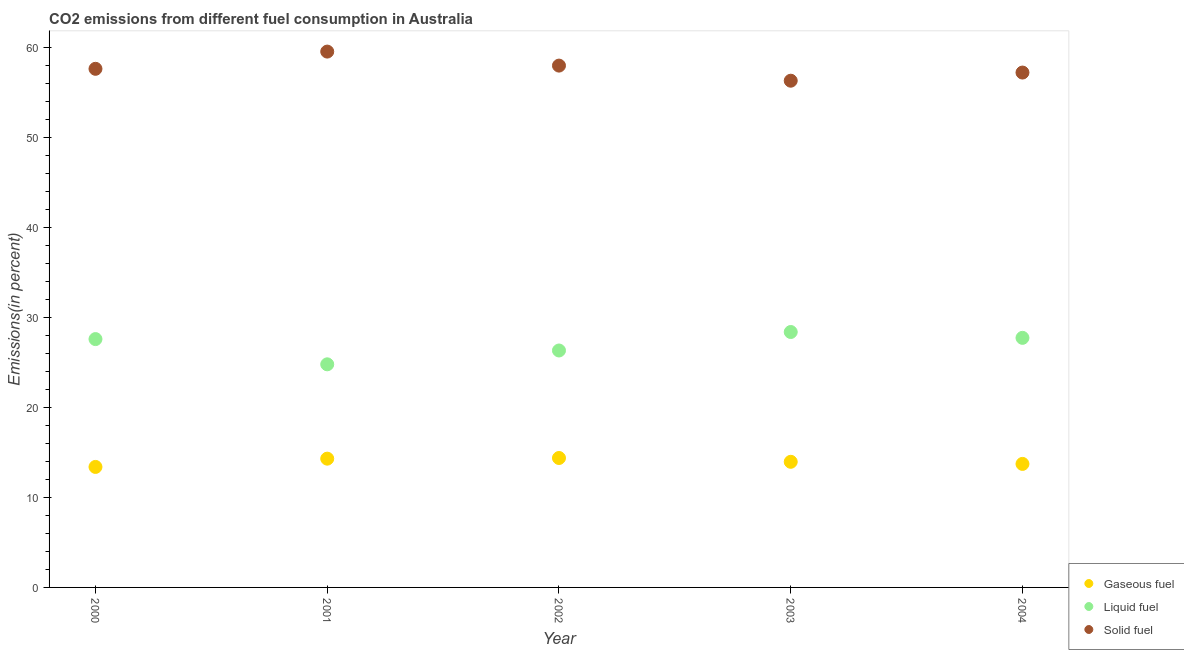How many different coloured dotlines are there?
Provide a succinct answer. 3. What is the percentage of gaseous fuel emission in 2004?
Your answer should be very brief. 13.74. Across all years, what is the maximum percentage of solid fuel emission?
Give a very brief answer. 59.58. Across all years, what is the minimum percentage of solid fuel emission?
Ensure brevity in your answer.  56.35. What is the total percentage of liquid fuel emission in the graph?
Make the answer very short. 134.93. What is the difference between the percentage of liquid fuel emission in 2000 and that in 2003?
Make the answer very short. -0.79. What is the difference between the percentage of gaseous fuel emission in 2002 and the percentage of solid fuel emission in 2004?
Provide a short and direct response. -42.86. What is the average percentage of solid fuel emission per year?
Offer a terse response. 57.78. In the year 2002, what is the difference between the percentage of solid fuel emission and percentage of gaseous fuel emission?
Provide a short and direct response. 43.63. What is the ratio of the percentage of solid fuel emission in 2000 to that in 2002?
Give a very brief answer. 0.99. Is the difference between the percentage of liquid fuel emission in 2001 and 2002 greater than the difference between the percentage of solid fuel emission in 2001 and 2002?
Keep it short and to the point. No. What is the difference between the highest and the second highest percentage of liquid fuel emission?
Offer a terse response. 0.65. What is the difference between the highest and the lowest percentage of liquid fuel emission?
Give a very brief answer. 3.59. In how many years, is the percentage of solid fuel emission greater than the average percentage of solid fuel emission taken over all years?
Provide a succinct answer. 2. How many years are there in the graph?
Your answer should be very brief. 5. What is the difference between two consecutive major ticks on the Y-axis?
Your response must be concise. 10. Does the graph contain any zero values?
Ensure brevity in your answer.  No. Where does the legend appear in the graph?
Ensure brevity in your answer.  Bottom right. How are the legend labels stacked?
Offer a terse response. Vertical. What is the title of the graph?
Offer a very short reply. CO2 emissions from different fuel consumption in Australia. What is the label or title of the Y-axis?
Provide a short and direct response. Emissions(in percent). What is the Emissions(in percent) of Gaseous fuel in 2000?
Your answer should be compact. 13.4. What is the Emissions(in percent) of Liquid fuel in 2000?
Your answer should be compact. 27.61. What is the Emissions(in percent) of Solid fuel in 2000?
Provide a short and direct response. 57.67. What is the Emissions(in percent) in Gaseous fuel in 2001?
Your answer should be very brief. 14.32. What is the Emissions(in percent) in Liquid fuel in 2001?
Offer a very short reply. 24.81. What is the Emissions(in percent) in Solid fuel in 2001?
Keep it short and to the point. 59.58. What is the Emissions(in percent) of Gaseous fuel in 2002?
Your answer should be very brief. 14.39. What is the Emissions(in percent) of Liquid fuel in 2002?
Keep it short and to the point. 26.35. What is the Emissions(in percent) in Solid fuel in 2002?
Your answer should be very brief. 58.03. What is the Emissions(in percent) in Gaseous fuel in 2003?
Keep it short and to the point. 13.97. What is the Emissions(in percent) in Liquid fuel in 2003?
Offer a very short reply. 28.4. What is the Emissions(in percent) in Solid fuel in 2003?
Your answer should be very brief. 56.35. What is the Emissions(in percent) in Gaseous fuel in 2004?
Offer a very short reply. 13.74. What is the Emissions(in percent) in Liquid fuel in 2004?
Your response must be concise. 27.75. What is the Emissions(in percent) in Solid fuel in 2004?
Provide a short and direct response. 57.25. Across all years, what is the maximum Emissions(in percent) in Gaseous fuel?
Keep it short and to the point. 14.39. Across all years, what is the maximum Emissions(in percent) in Liquid fuel?
Provide a short and direct response. 28.4. Across all years, what is the maximum Emissions(in percent) of Solid fuel?
Provide a succinct answer. 59.58. Across all years, what is the minimum Emissions(in percent) in Gaseous fuel?
Offer a terse response. 13.4. Across all years, what is the minimum Emissions(in percent) in Liquid fuel?
Offer a terse response. 24.81. Across all years, what is the minimum Emissions(in percent) of Solid fuel?
Offer a terse response. 56.35. What is the total Emissions(in percent) in Gaseous fuel in the graph?
Your answer should be compact. 69.81. What is the total Emissions(in percent) of Liquid fuel in the graph?
Give a very brief answer. 134.93. What is the total Emissions(in percent) of Solid fuel in the graph?
Ensure brevity in your answer.  288.88. What is the difference between the Emissions(in percent) of Gaseous fuel in 2000 and that in 2001?
Your response must be concise. -0.92. What is the difference between the Emissions(in percent) of Liquid fuel in 2000 and that in 2001?
Ensure brevity in your answer.  2.81. What is the difference between the Emissions(in percent) of Solid fuel in 2000 and that in 2001?
Provide a succinct answer. -1.92. What is the difference between the Emissions(in percent) in Gaseous fuel in 2000 and that in 2002?
Offer a terse response. -0.99. What is the difference between the Emissions(in percent) in Liquid fuel in 2000 and that in 2002?
Provide a succinct answer. 1.27. What is the difference between the Emissions(in percent) in Solid fuel in 2000 and that in 2002?
Give a very brief answer. -0.36. What is the difference between the Emissions(in percent) of Gaseous fuel in 2000 and that in 2003?
Give a very brief answer. -0.57. What is the difference between the Emissions(in percent) of Liquid fuel in 2000 and that in 2003?
Make the answer very short. -0.79. What is the difference between the Emissions(in percent) in Solid fuel in 2000 and that in 2003?
Make the answer very short. 1.32. What is the difference between the Emissions(in percent) of Gaseous fuel in 2000 and that in 2004?
Give a very brief answer. -0.34. What is the difference between the Emissions(in percent) in Liquid fuel in 2000 and that in 2004?
Ensure brevity in your answer.  -0.14. What is the difference between the Emissions(in percent) in Solid fuel in 2000 and that in 2004?
Offer a very short reply. 0.42. What is the difference between the Emissions(in percent) of Gaseous fuel in 2001 and that in 2002?
Your response must be concise. -0.07. What is the difference between the Emissions(in percent) of Liquid fuel in 2001 and that in 2002?
Your response must be concise. -1.54. What is the difference between the Emissions(in percent) of Solid fuel in 2001 and that in 2002?
Offer a terse response. 1.56. What is the difference between the Emissions(in percent) of Gaseous fuel in 2001 and that in 2003?
Ensure brevity in your answer.  0.35. What is the difference between the Emissions(in percent) of Liquid fuel in 2001 and that in 2003?
Keep it short and to the point. -3.59. What is the difference between the Emissions(in percent) in Solid fuel in 2001 and that in 2003?
Provide a succinct answer. 3.24. What is the difference between the Emissions(in percent) of Gaseous fuel in 2001 and that in 2004?
Provide a succinct answer. 0.58. What is the difference between the Emissions(in percent) of Liquid fuel in 2001 and that in 2004?
Your answer should be compact. -2.94. What is the difference between the Emissions(in percent) of Solid fuel in 2001 and that in 2004?
Offer a terse response. 2.33. What is the difference between the Emissions(in percent) in Gaseous fuel in 2002 and that in 2003?
Provide a short and direct response. 0.42. What is the difference between the Emissions(in percent) of Liquid fuel in 2002 and that in 2003?
Your response must be concise. -2.06. What is the difference between the Emissions(in percent) of Solid fuel in 2002 and that in 2003?
Provide a short and direct response. 1.68. What is the difference between the Emissions(in percent) of Gaseous fuel in 2002 and that in 2004?
Your response must be concise. 0.66. What is the difference between the Emissions(in percent) of Liquid fuel in 2002 and that in 2004?
Your answer should be very brief. -1.41. What is the difference between the Emissions(in percent) in Solid fuel in 2002 and that in 2004?
Provide a short and direct response. 0.77. What is the difference between the Emissions(in percent) of Gaseous fuel in 2003 and that in 2004?
Ensure brevity in your answer.  0.23. What is the difference between the Emissions(in percent) in Liquid fuel in 2003 and that in 2004?
Your answer should be very brief. 0.65. What is the difference between the Emissions(in percent) in Solid fuel in 2003 and that in 2004?
Offer a terse response. -0.91. What is the difference between the Emissions(in percent) in Gaseous fuel in 2000 and the Emissions(in percent) in Liquid fuel in 2001?
Provide a succinct answer. -11.41. What is the difference between the Emissions(in percent) of Gaseous fuel in 2000 and the Emissions(in percent) of Solid fuel in 2001?
Provide a succinct answer. -46.19. What is the difference between the Emissions(in percent) of Liquid fuel in 2000 and the Emissions(in percent) of Solid fuel in 2001?
Your answer should be very brief. -31.97. What is the difference between the Emissions(in percent) of Gaseous fuel in 2000 and the Emissions(in percent) of Liquid fuel in 2002?
Make the answer very short. -12.95. What is the difference between the Emissions(in percent) of Gaseous fuel in 2000 and the Emissions(in percent) of Solid fuel in 2002?
Keep it short and to the point. -44.63. What is the difference between the Emissions(in percent) of Liquid fuel in 2000 and the Emissions(in percent) of Solid fuel in 2002?
Offer a terse response. -30.41. What is the difference between the Emissions(in percent) of Gaseous fuel in 2000 and the Emissions(in percent) of Liquid fuel in 2003?
Your answer should be very brief. -15. What is the difference between the Emissions(in percent) of Gaseous fuel in 2000 and the Emissions(in percent) of Solid fuel in 2003?
Keep it short and to the point. -42.95. What is the difference between the Emissions(in percent) of Liquid fuel in 2000 and the Emissions(in percent) of Solid fuel in 2003?
Offer a terse response. -28.73. What is the difference between the Emissions(in percent) in Gaseous fuel in 2000 and the Emissions(in percent) in Liquid fuel in 2004?
Your response must be concise. -14.35. What is the difference between the Emissions(in percent) in Gaseous fuel in 2000 and the Emissions(in percent) in Solid fuel in 2004?
Your response must be concise. -43.85. What is the difference between the Emissions(in percent) in Liquid fuel in 2000 and the Emissions(in percent) in Solid fuel in 2004?
Your response must be concise. -29.64. What is the difference between the Emissions(in percent) in Gaseous fuel in 2001 and the Emissions(in percent) in Liquid fuel in 2002?
Ensure brevity in your answer.  -12.03. What is the difference between the Emissions(in percent) in Gaseous fuel in 2001 and the Emissions(in percent) in Solid fuel in 2002?
Provide a succinct answer. -43.71. What is the difference between the Emissions(in percent) in Liquid fuel in 2001 and the Emissions(in percent) in Solid fuel in 2002?
Your answer should be compact. -33.22. What is the difference between the Emissions(in percent) in Gaseous fuel in 2001 and the Emissions(in percent) in Liquid fuel in 2003?
Ensure brevity in your answer.  -14.08. What is the difference between the Emissions(in percent) in Gaseous fuel in 2001 and the Emissions(in percent) in Solid fuel in 2003?
Provide a short and direct response. -42.03. What is the difference between the Emissions(in percent) in Liquid fuel in 2001 and the Emissions(in percent) in Solid fuel in 2003?
Your answer should be very brief. -31.54. What is the difference between the Emissions(in percent) of Gaseous fuel in 2001 and the Emissions(in percent) of Liquid fuel in 2004?
Keep it short and to the point. -13.43. What is the difference between the Emissions(in percent) of Gaseous fuel in 2001 and the Emissions(in percent) of Solid fuel in 2004?
Ensure brevity in your answer.  -42.93. What is the difference between the Emissions(in percent) of Liquid fuel in 2001 and the Emissions(in percent) of Solid fuel in 2004?
Provide a succinct answer. -32.44. What is the difference between the Emissions(in percent) of Gaseous fuel in 2002 and the Emissions(in percent) of Liquid fuel in 2003?
Keep it short and to the point. -14.01. What is the difference between the Emissions(in percent) in Gaseous fuel in 2002 and the Emissions(in percent) in Solid fuel in 2003?
Make the answer very short. -41.95. What is the difference between the Emissions(in percent) in Liquid fuel in 2002 and the Emissions(in percent) in Solid fuel in 2003?
Make the answer very short. -30. What is the difference between the Emissions(in percent) in Gaseous fuel in 2002 and the Emissions(in percent) in Liquid fuel in 2004?
Ensure brevity in your answer.  -13.36. What is the difference between the Emissions(in percent) of Gaseous fuel in 2002 and the Emissions(in percent) of Solid fuel in 2004?
Your answer should be compact. -42.86. What is the difference between the Emissions(in percent) in Liquid fuel in 2002 and the Emissions(in percent) in Solid fuel in 2004?
Your answer should be compact. -30.91. What is the difference between the Emissions(in percent) in Gaseous fuel in 2003 and the Emissions(in percent) in Liquid fuel in 2004?
Provide a succinct answer. -13.78. What is the difference between the Emissions(in percent) of Gaseous fuel in 2003 and the Emissions(in percent) of Solid fuel in 2004?
Provide a short and direct response. -43.28. What is the difference between the Emissions(in percent) in Liquid fuel in 2003 and the Emissions(in percent) in Solid fuel in 2004?
Keep it short and to the point. -28.85. What is the average Emissions(in percent) of Gaseous fuel per year?
Your answer should be compact. 13.96. What is the average Emissions(in percent) of Liquid fuel per year?
Keep it short and to the point. 26.99. What is the average Emissions(in percent) of Solid fuel per year?
Your response must be concise. 57.78. In the year 2000, what is the difference between the Emissions(in percent) of Gaseous fuel and Emissions(in percent) of Liquid fuel?
Keep it short and to the point. -14.22. In the year 2000, what is the difference between the Emissions(in percent) in Gaseous fuel and Emissions(in percent) in Solid fuel?
Ensure brevity in your answer.  -44.27. In the year 2000, what is the difference between the Emissions(in percent) in Liquid fuel and Emissions(in percent) in Solid fuel?
Provide a succinct answer. -30.05. In the year 2001, what is the difference between the Emissions(in percent) of Gaseous fuel and Emissions(in percent) of Liquid fuel?
Offer a terse response. -10.49. In the year 2001, what is the difference between the Emissions(in percent) of Gaseous fuel and Emissions(in percent) of Solid fuel?
Your answer should be very brief. -45.27. In the year 2001, what is the difference between the Emissions(in percent) in Liquid fuel and Emissions(in percent) in Solid fuel?
Your answer should be very brief. -34.78. In the year 2002, what is the difference between the Emissions(in percent) in Gaseous fuel and Emissions(in percent) in Liquid fuel?
Keep it short and to the point. -11.95. In the year 2002, what is the difference between the Emissions(in percent) of Gaseous fuel and Emissions(in percent) of Solid fuel?
Your answer should be very brief. -43.63. In the year 2002, what is the difference between the Emissions(in percent) in Liquid fuel and Emissions(in percent) in Solid fuel?
Provide a succinct answer. -31.68. In the year 2003, what is the difference between the Emissions(in percent) of Gaseous fuel and Emissions(in percent) of Liquid fuel?
Give a very brief answer. -14.43. In the year 2003, what is the difference between the Emissions(in percent) in Gaseous fuel and Emissions(in percent) in Solid fuel?
Offer a terse response. -42.38. In the year 2003, what is the difference between the Emissions(in percent) of Liquid fuel and Emissions(in percent) of Solid fuel?
Provide a short and direct response. -27.94. In the year 2004, what is the difference between the Emissions(in percent) of Gaseous fuel and Emissions(in percent) of Liquid fuel?
Your answer should be very brief. -14.02. In the year 2004, what is the difference between the Emissions(in percent) of Gaseous fuel and Emissions(in percent) of Solid fuel?
Make the answer very short. -43.52. In the year 2004, what is the difference between the Emissions(in percent) of Liquid fuel and Emissions(in percent) of Solid fuel?
Your response must be concise. -29.5. What is the ratio of the Emissions(in percent) in Gaseous fuel in 2000 to that in 2001?
Keep it short and to the point. 0.94. What is the ratio of the Emissions(in percent) in Liquid fuel in 2000 to that in 2001?
Provide a short and direct response. 1.11. What is the ratio of the Emissions(in percent) of Solid fuel in 2000 to that in 2001?
Offer a very short reply. 0.97. What is the ratio of the Emissions(in percent) of Liquid fuel in 2000 to that in 2002?
Your answer should be compact. 1.05. What is the ratio of the Emissions(in percent) of Solid fuel in 2000 to that in 2002?
Offer a very short reply. 0.99. What is the ratio of the Emissions(in percent) in Gaseous fuel in 2000 to that in 2003?
Your answer should be compact. 0.96. What is the ratio of the Emissions(in percent) in Liquid fuel in 2000 to that in 2003?
Offer a terse response. 0.97. What is the ratio of the Emissions(in percent) of Solid fuel in 2000 to that in 2003?
Ensure brevity in your answer.  1.02. What is the ratio of the Emissions(in percent) in Gaseous fuel in 2000 to that in 2004?
Your answer should be very brief. 0.98. What is the ratio of the Emissions(in percent) in Solid fuel in 2000 to that in 2004?
Provide a short and direct response. 1.01. What is the ratio of the Emissions(in percent) of Gaseous fuel in 2001 to that in 2002?
Give a very brief answer. 0.99. What is the ratio of the Emissions(in percent) in Liquid fuel in 2001 to that in 2002?
Your answer should be very brief. 0.94. What is the ratio of the Emissions(in percent) of Solid fuel in 2001 to that in 2002?
Offer a terse response. 1.03. What is the ratio of the Emissions(in percent) in Gaseous fuel in 2001 to that in 2003?
Make the answer very short. 1.03. What is the ratio of the Emissions(in percent) in Liquid fuel in 2001 to that in 2003?
Ensure brevity in your answer.  0.87. What is the ratio of the Emissions(in percent) of Solid fuel in 2001 to that in 2003?
Keep it short and to the point. 1.06. What is the ratio of the Emissions(in percent) in Gaseous fuel in 2001 to that in 2004?
Your response must be concise. 1.04. What is the ratio of the Emissions(in percent) in Liquid fuel in 2001 to that in 2004?
Ensure brevity in your answer.  0.89. What is the ratio of the Emissions(in percent) of Solid fuel in 2001 to that in 2004?
Your response must be concise. 1.04. What is the ratio of the Emissions(in percent) in Gaseous fuel in 2002 to that in 2003?
Offer a very short reply. 1.03. What is the ratio of the Emissions(in percent) of Liquid fuel in 2002 to that in 2003?
Offer a very short reply. 0.93. What is the ratio of the Emissions(in percent) of Solid fuel in 2002 to that in 2003?
Offer a very short reply. 1.03. What is the ratio of the Emissions(in percent) of Gaseous fuel in 2002 to that in 2004?
Your response must be concise. 1.05. What is the ratio of the Emissions(in percent) in Liquid fuel in 2002 to that in 2004?
Ensure brevity in your answer.  0.95. What is the ratio of the Emissions(in percent) in Solid fuel in 2002 to that in 2004?
Offer a very short reply. 1.01. What is the ratio of the Emissions(in percent) of Gaseous fuel in 2003 to that in 2004?
Offer a terse response. 1.02. What is the ratio of the Emissions(in percent) in Liquid fuel in 2003 to that in 2004?
Keep it short and to the point. 1.02. What is the ratio of the Emissions(in percent) of Solid fuel in 2003 to that in 2004?
Provide a succinct answer. 0.98. What is the difference between the highest and the second highest Emissions(in percent) of Gaseous fuel?
Keep it short and to the point. 0.07. What is the difference between the highest and the second highest Emissions(in percent) of Liquid fuel?
Ensure brevity in your answer.  0.65. What is the difference between the highest and the second highest Emissions(in percent) of Solid fuel?
Your answer should be very brief. 1.56. What is the difference between the highest and the lowest Emissions(in percent) of Liquid fuel?
Your answer should be compact. 3.59. What is the difference between the highest and the lowest Emissions(in percent) in Solid fuel?
Ensure brevity in your answer.  3.24. 